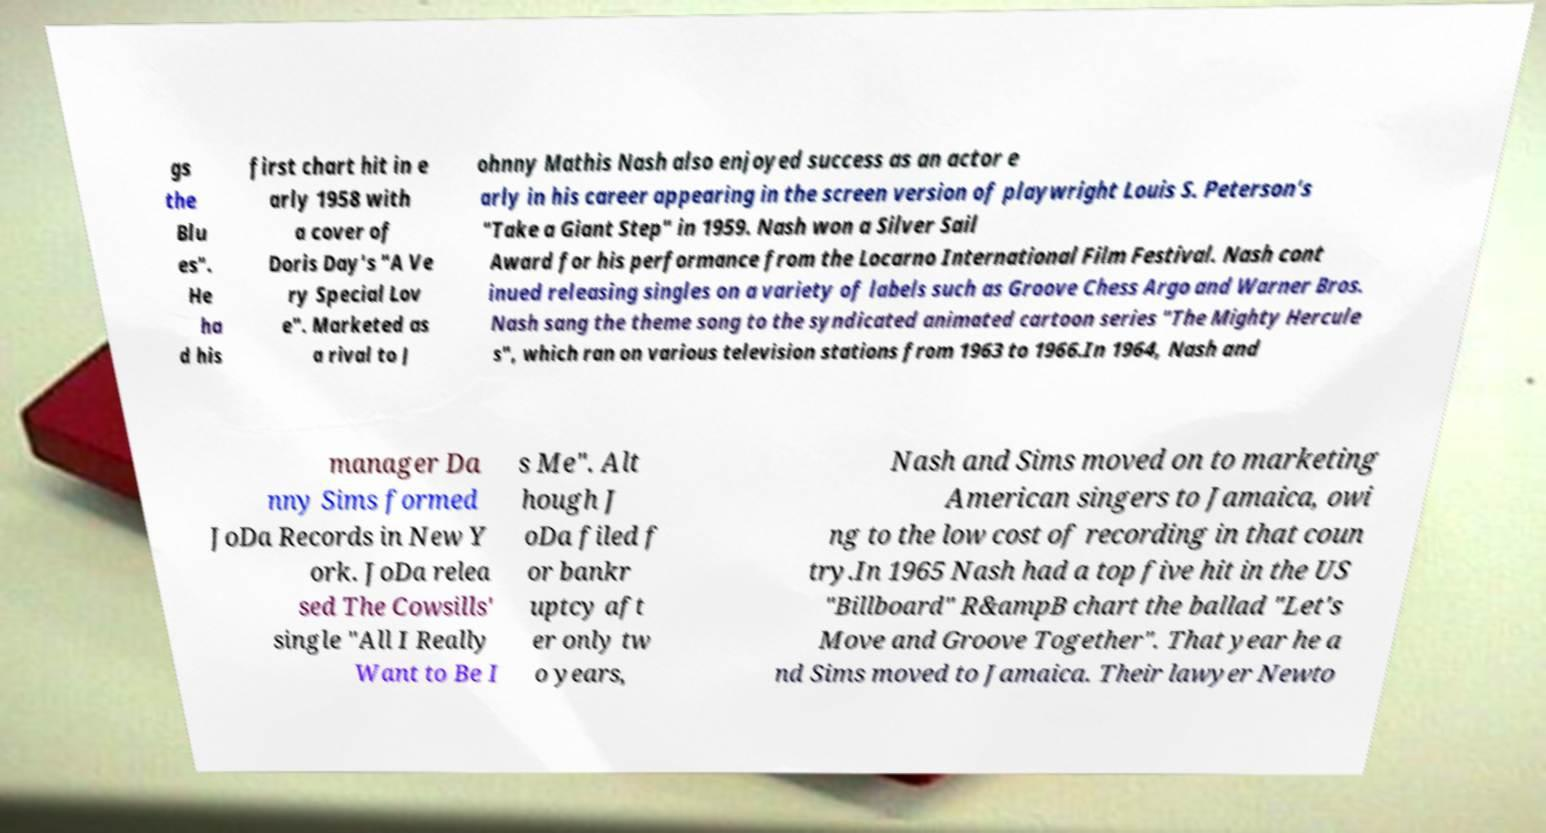Please identify and transcribe the text found in this image. gs the Blu es". He ha d his first chart hit in e arly 1958 with a cover of Doris Day's "A Ve ry Special Lov e". Marketed as a rival to J ohnny Mathis Nash also enjoyed success as an actor e arly in his career appearing in the screen version of playwright Louis S. Peterson's "Take a Giant Step" in 1959. Nash won a Silver Sail Award for his performance from the Locarno International Film Festival. Nash cont inued releasing singles on a variety of labels such as Groove Chess Argo and Warner Bros. Nash sang the theme song to the syndicated animated cartoon series "The Mighty Hercule s", which ran on various television stations from 1963 to 1966.In 1964, Nash and manager Da nny Sims formed JoDa Records in New Y ork. JoDa relea sed The Cowsills' single "All I Really Want to Be I s Me". Alt hough J oDa filed f or bankr uptcy aft er only tw o years, Nash and Sims moved on to marketing American singers to Jamaica, owi ng to the low cost of recording in that coun try.In 1965 Nash had a top five hit in the US "Billboard" R&ampB chart the ballad "Let's Move and Groove Together". That year he a nd Sims moved to Jamaica. Their lawyer Newto 